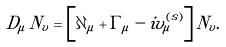<formula> <loc_0><loc_0><loc_500><loc_500>D _ { \mu } \, N _ { v } = \left [ \partial _ { \mu } + \Gamma _ { \mu } - i v _ { \mu } ^ { ( s ) } \right ] N _ { v } .</formula> 